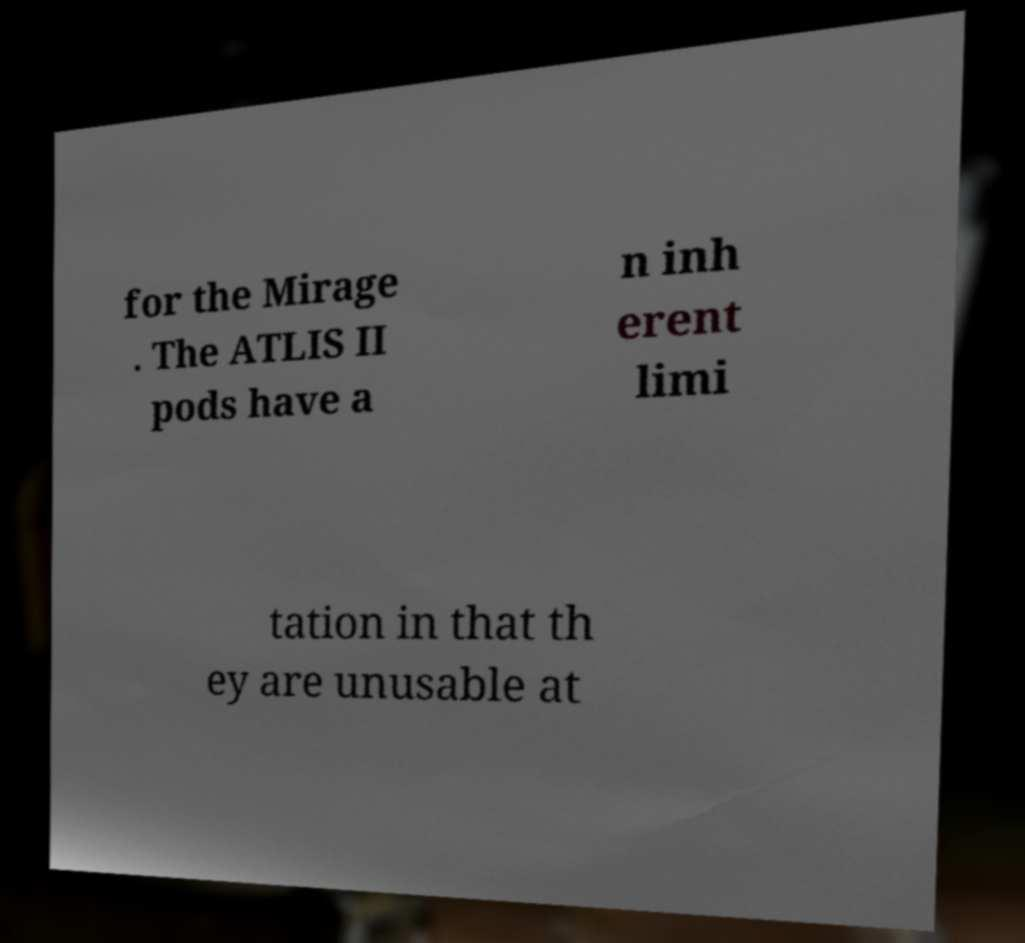Could you extract and type out the text from this image? for the Mirage . The ATLIS II pods have a n inh erent limi tation in that th ey are unusable at 